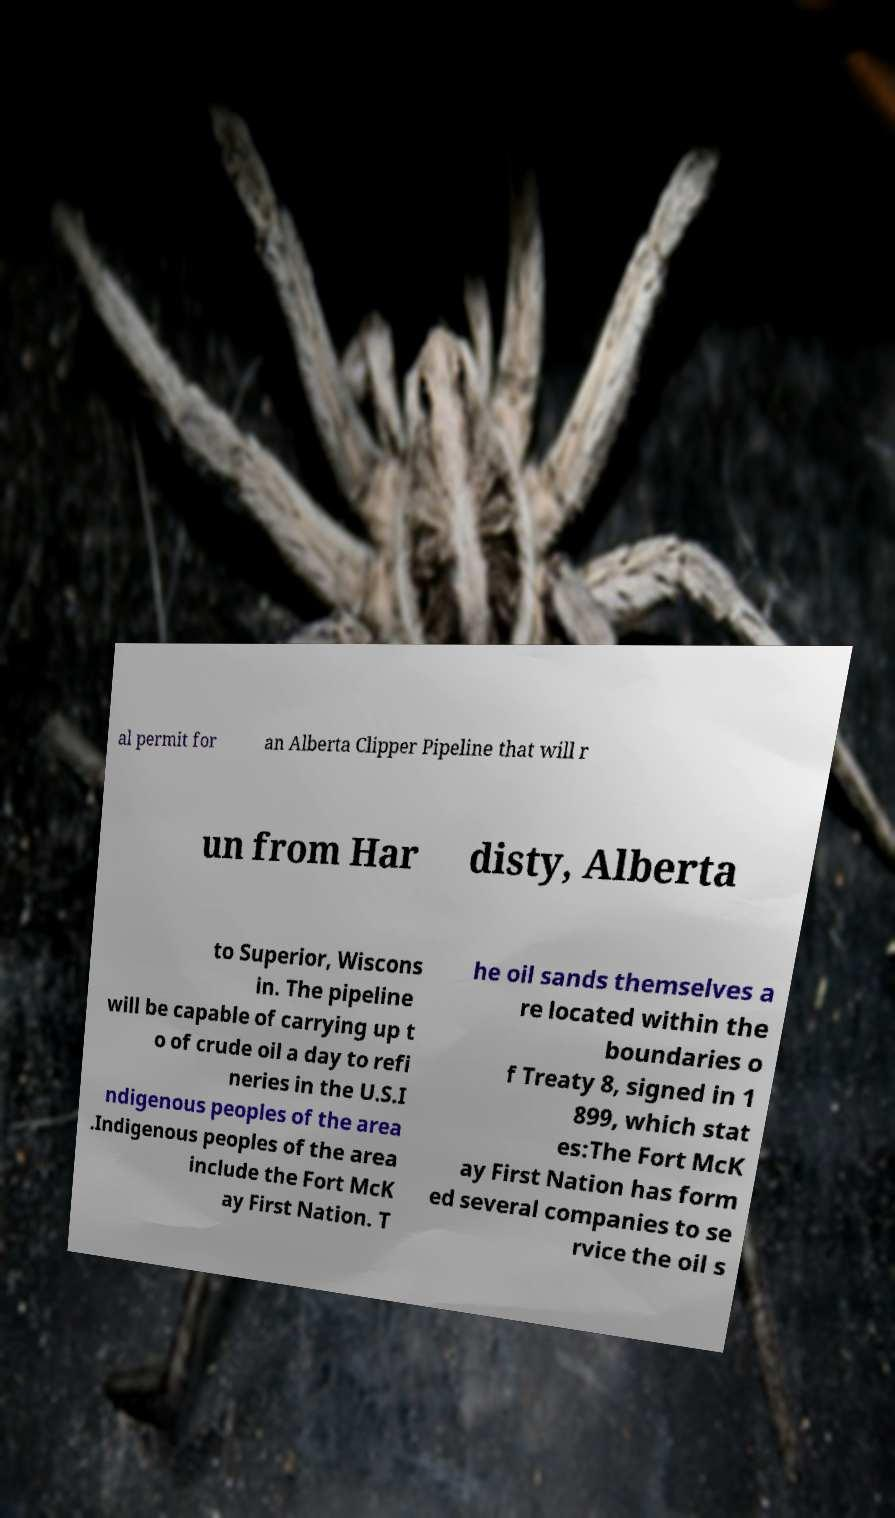Can you accurately transcribe the text from the provided image for me? al permit for an Alberta Clipper Pipeline that will r un from Har disty, Alberta to Superior, Wiscons in. The pipeline will be capable of carrying up t o of crude oil a day to refi neries in the U.S.I ndigenous peoples of the area .Indigenous peoples of the area include the Fort McK ay First Nation. T he oil sands themselves a re located within the boundaries o f Treaty 8, signed in 1 899, which stat es:The Fort McK ay First Nation has form ed several companies to se rvice the oil s 